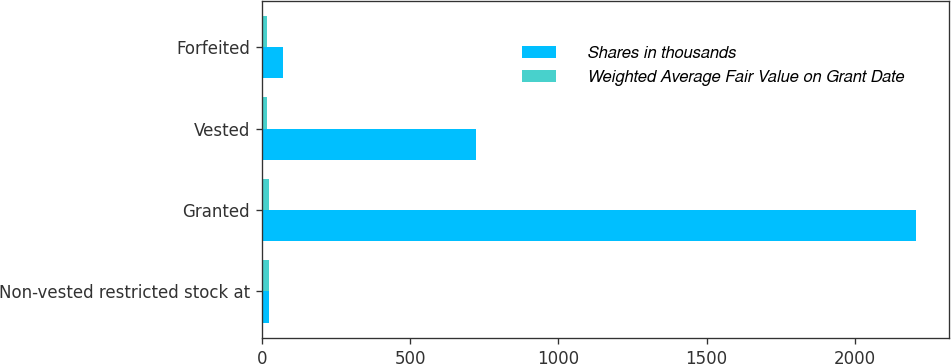<chart> <loc_0><loc_0><loc_500><loc_500><stacked_bar_chart><ecel><fcel>Non-vested restricted stock at<fcel>Granted<fcel>Vested<fcel>Forfeited<nl><fcel>Shares in thousands<fcel>25.16<fcel>2207<fcel>723<fcel>73<nl><fcel>Weighted Average Fair Value on Grant Date<fcel>23.23<fcel>25.16<fcel>17.73<fcel>18.18<nl></chart> 